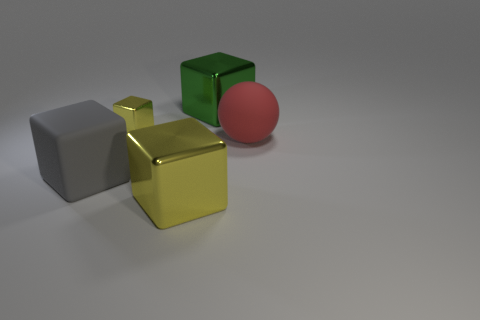Is the size of the gray object the same as the red sphere?
Your response must be concise. Yes. Are there fewer tiny metal blocks that are in front of the large red rubber ball than gray rubber objects in front of the big yellow block?
Your answer should be compact. No. Is there any other thing that is the same size as the gray cube?
Provide a short and direct response. Yes. The green block is what size?
Ensure brevity in your answer.  Large. How many big objects are either red matte things or gray spheres?
Offer a terse response. 1. Is the size of the sphere the same as the metal cube in front of the red object?
Your answer should be very brief. Yes. Is there any other thing that has the same shape as the large gray object?
Your response must be concise. Yes. How many brown metallic balls are there?
Ensure brevity in your answer.  0. What number of yellow objects are either matte cubes or big matte spheres?
Offer a very short reply. 0. Is the thing on the left side of the tiny object made of the same material as the big green cube?
Keep it short and to the point. No. 